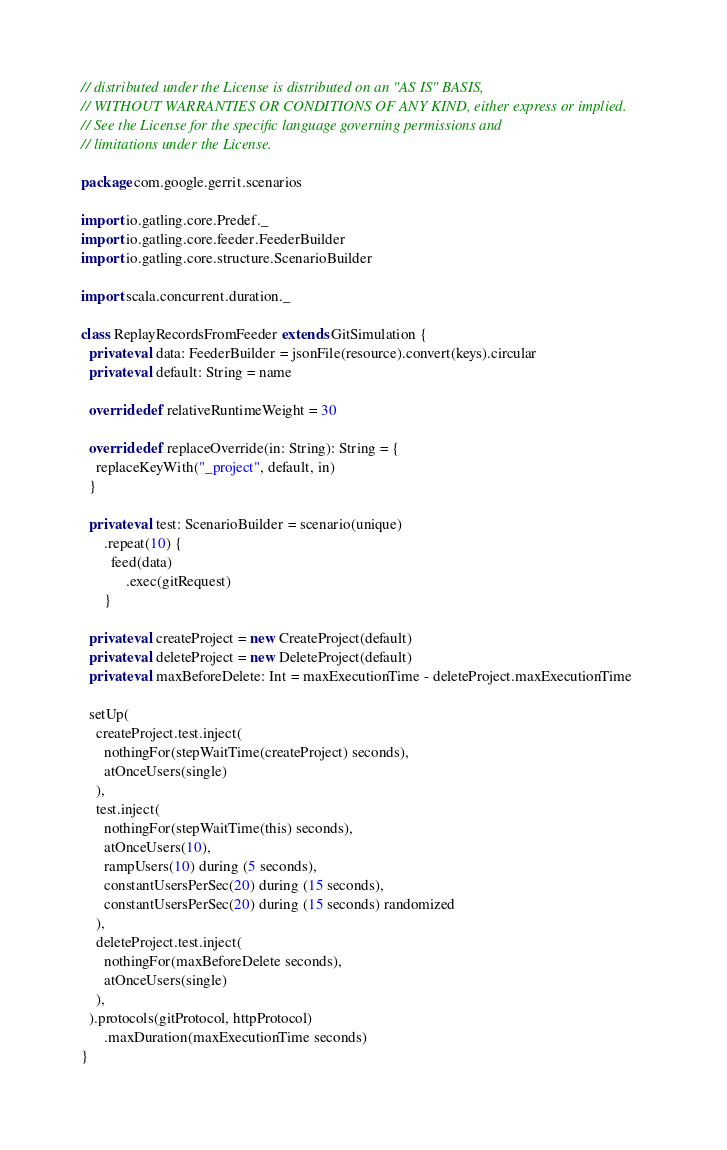Convert code to text. <code><loc_0><loc_0><loc_500><loc_500><_Scala_>// distributed under the License is distributed on an "AS IS" BASIS,
// WITHOUT WARRANTIES OR CONDITIONS OF ANY KIND, either express or implied.
// See the License for the specific language governing permissions and
// limitations under the License.

package com.google.gerrit.scenarios

import io.gatling.core.Predef._
import io.gatling.core.feeder.FeederBuilder
import io.gatling.core.structure.ScenarioBuilder

import scala.concurrent.duration._

class ReplayRecordsFromFeeder extends GitSimulation {
  private val data: FeederBuilder = jsonFile(resource).convert(keys).circular
  private val default: String = name

  override def relativeRuntimeWeight = 30

  override def replaceOverride(in: String): String = {
    replaceKeyWith("_project", default, in)
  }

  private val test: ScenarioBuilder = scenario(unique)
      .repeat(10) {
        feed(data)
            .exec(gitRequest)
      }

  private val createProject = new CreateProject(default)
  private val deleteProject = new DeleteProject(default)
  private val maxBeforeDelete: Int = maxExecutionTime - deleteProject.maxExecutionTime

  setUp(
    createProject.test.inject(
      nothingFor(stepWaitTime(createProject) seconds),
      atOnceUsers(single)
    ),
    test.inject(
      nothingFor(stepWaitTime(this) seconds),
      atOnceUsers(10),
      rampUsers(10) during (5 seconds),
      constantUsersPerSec(20) during (15 seconds),
      constantUsersPerSec(20) during (15 seconds) randomized
    ),
    deleteProject.test.inject(
      nothingFor(maxBeforeDelete seconds),
      atOnceUsers(single)
    ),
  ).protocols(gitProtocol, httpProtocol)
      .maxDuration(maxExecutionTime seconds)
}
</code> 